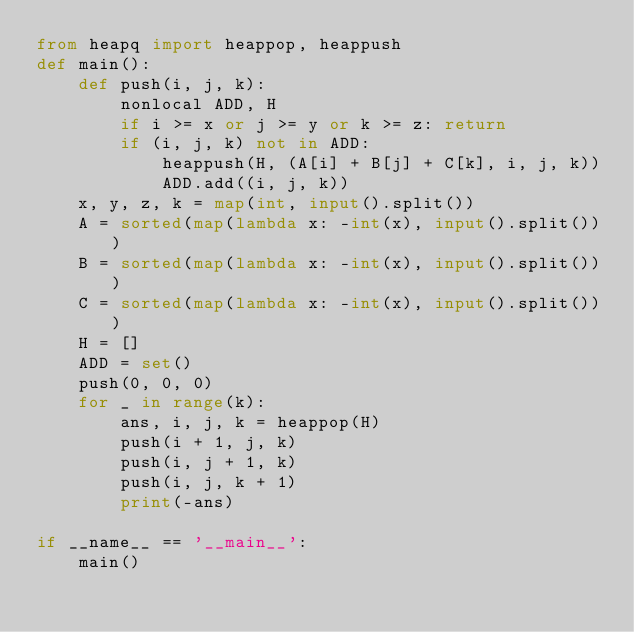Convert code to text. <code><loc_0><loc_0><loc_500><loc_500><_Python_>from heapq import heappop, heappush
def main():
    def push(i, j, k):
        nonlocal ADD, H
        if i >= x or j >= y or k >= z: return
        if (i, j, k) not in ADD:
            heappush(H, (A[i] + B[j] + C[k], i, j, k))
            ADD.add((i, j, k))
    x, y, z, k = map(int, input().split())
    A = sorted(map(lambda x: -int(x), input().split()))
    B = sorted(map(lambda x: -int(x), input().split()))
    C = sorted(map(lambda x: -int(x), input().split()))
    H = []
    ADD = set()
    push(0, 0, 0)
    for _ in range(k):
        ans, i, j, k = heappop(H)
        push(i + 1, j, k)
        push(i, j + 1, k)
        push(i, j, k + 1)
        print(-ans)

if __name__ == '__main__':
    main()
</code> 